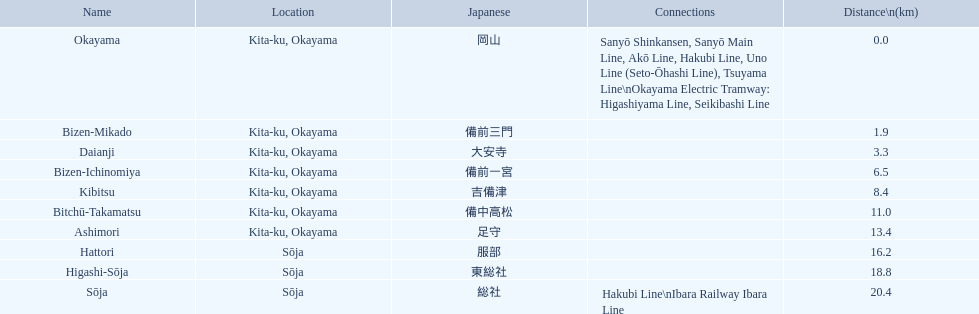What are the members of the kibi line? Okayama, Bizen-Mikado, Daianji, Bizen-Ichinomiya, Kibitsu, Bitchū-Takamatsu, Ashimori, Hattori, Higashi-Sōja, Sōja. Which of them have a distance of more than 1 km? Bizen-Mikado, Daianji, Bizen-Ichinomiya, Kibitsu, Bitchū-Takamatsu, Ashimori, Hattori, Higashi-Sōja, Sōja. Which of them have a distance of less than 2 km? Okayama, Bizen-Mikado. Which has a distance between 1 km and 2 km? Bizen-Mikado. 